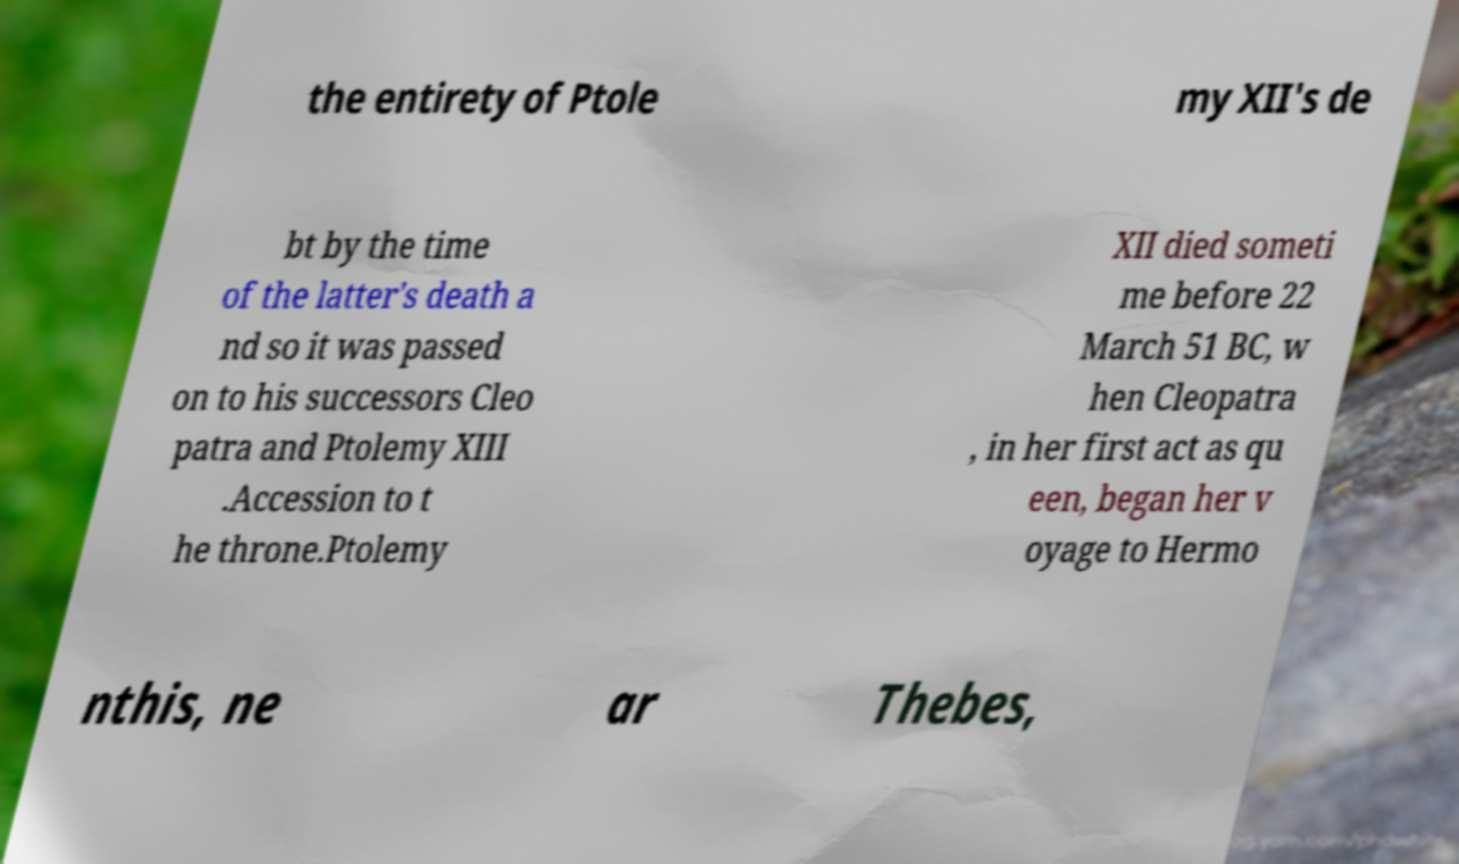Can you read and provide the text displayed in the image?This photo seems to have some interesting text. Can you extract and type it out for me? the entirety of Ptole my XII's de bt by the time of the latter's death a nd so it was passed on to his successors Cleo patra and Ptolemy XIII .Accession to t he throne.Ptolemy XII died someti me before 22 March 51 BC, w hen Cleopatra , in her first act as qu een, began her v oyage to Hermo nthis, ne ar Thebes, 